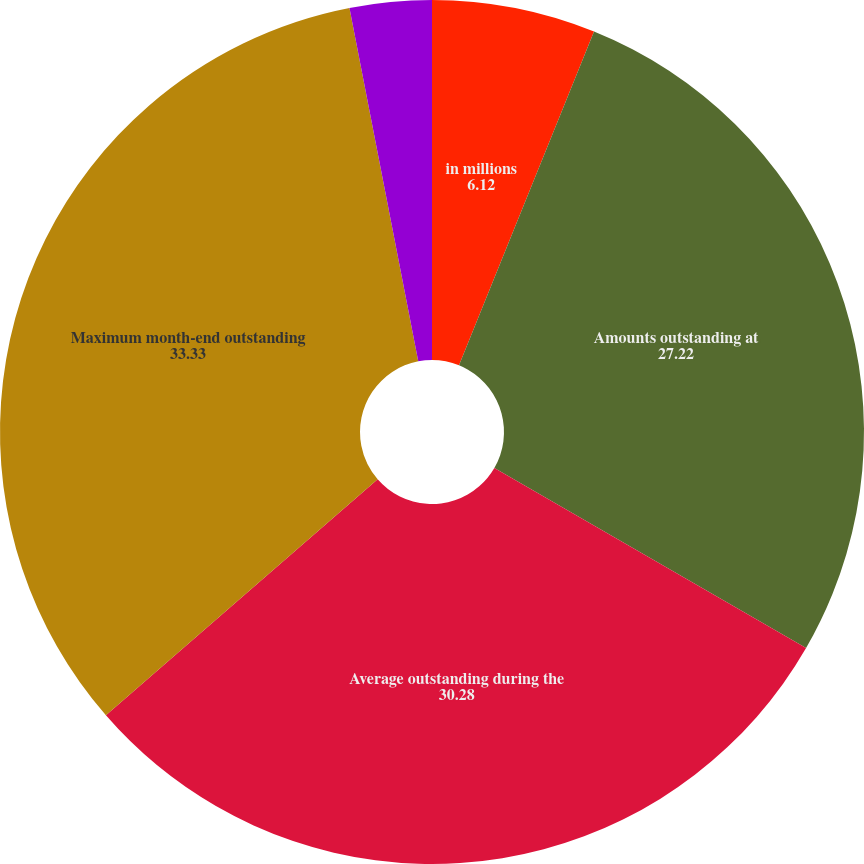<chart> <loc_0><loc_0><loc_500><loc_500><pie_chart><fcel>in millions<fcel>Amounts outstanding at<fcel>Average outstanding during the<fcel>Maximum month-end outstanding<fcel>During the year<fcel>At year-end<nl><fcel>6.12%<fcel>27.22%<fcel>30.28%<fcel>33.33%<fcel>3.06%<fcel>0.0%<nl></chart> 